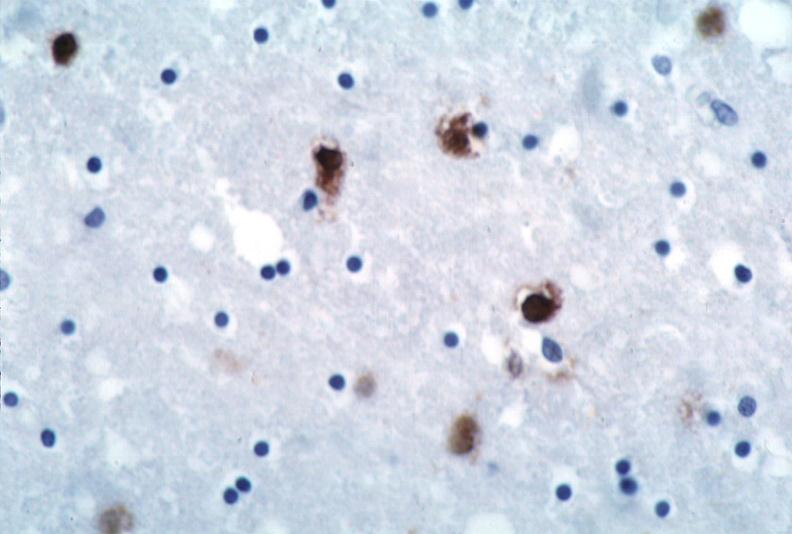s malignant lymphoma large cell type present?
Answer the question using a single word or phrase. No 